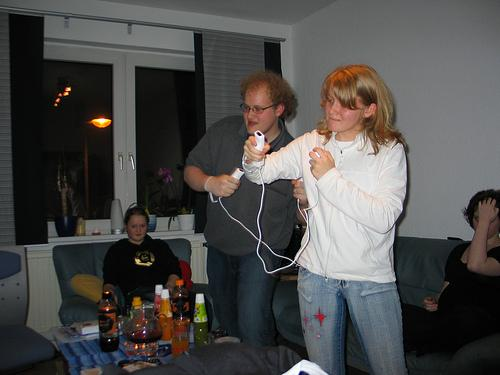Give a brief description of the setting and environment of the image. The scene is indoors, featuring a group of people playing video games and enjoying drinks in a room with a window in the house. Identify the primary clothing worn by the male and female individuals in the image. The man wears a gray short sleeve pullover and blue jeans, while the woman wears a white long sleeve jacket and blue jeans with a red star. Describe the woman's jeans in the image. The woman wears blue jeans decorated with a red star. How many people are sitting and what are they doing? Two people are sitting, one girl is sitting down on a sofa and another person is also sitting. Both are watching others play video games. Identify the gaming console being used by the people in the image. Nintendo Wii. What is the main activity taking place in the image? Playing video games at a party while drinking various types of beverages. Are there any flowers present in the image? If so, describe them. Yes, there are purple flowers in a white vase. How many people are engaged in playing video games while standing? Two people, a man and a woman, are standing up to play video games. What objects are placed on the table and how many bottles are there? Various types of drinks including several bottles, a white Wii controller, and many beverages. There are 6 bottles on the table. Can you describe the hairstyles and accessories worn by the individuals in the image? The man has blond curly hair and wire rim glasses, while the girl has long blond hair. The man holds a Wii hand held device. 